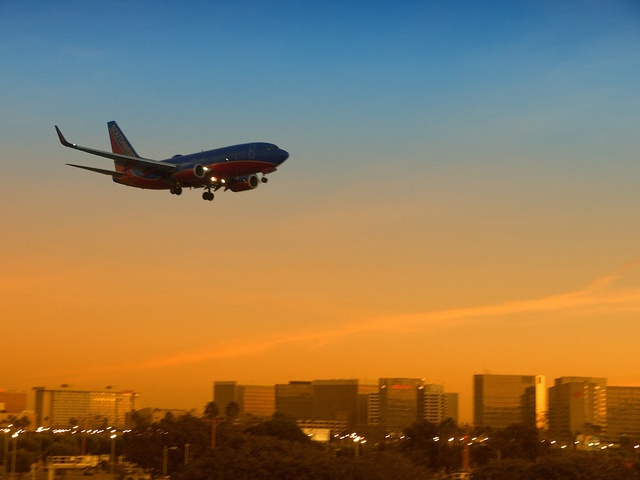Describe the objects in this image and their specific colors. I can see a airplane in blue, black, maroon, and gray tones in this image. 